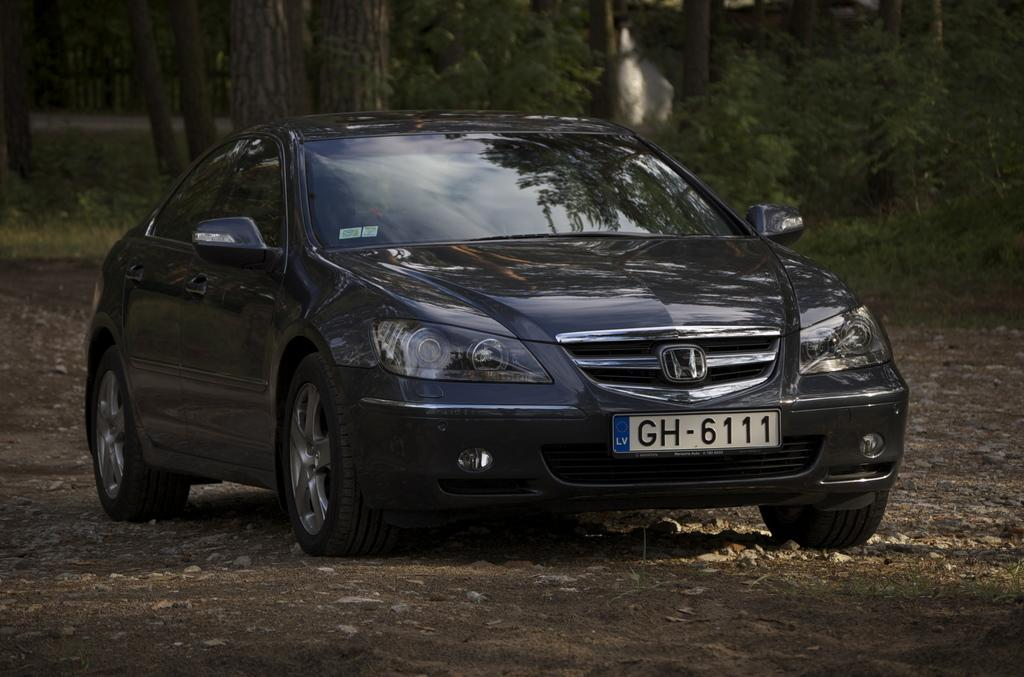What is the main subject of the image? There is a car in the image. What color is the car? The car is black. Where is the car located in the image? The car is on the ground. Can you describe the car's number plate? The car has a visible number plate. What can be seen in the background of the image? There are many trees in the background of the image. What songs can be heard playing from the moon in the image? There is no moon or music present in the image; it features a black car on the ground with trees in the background. 